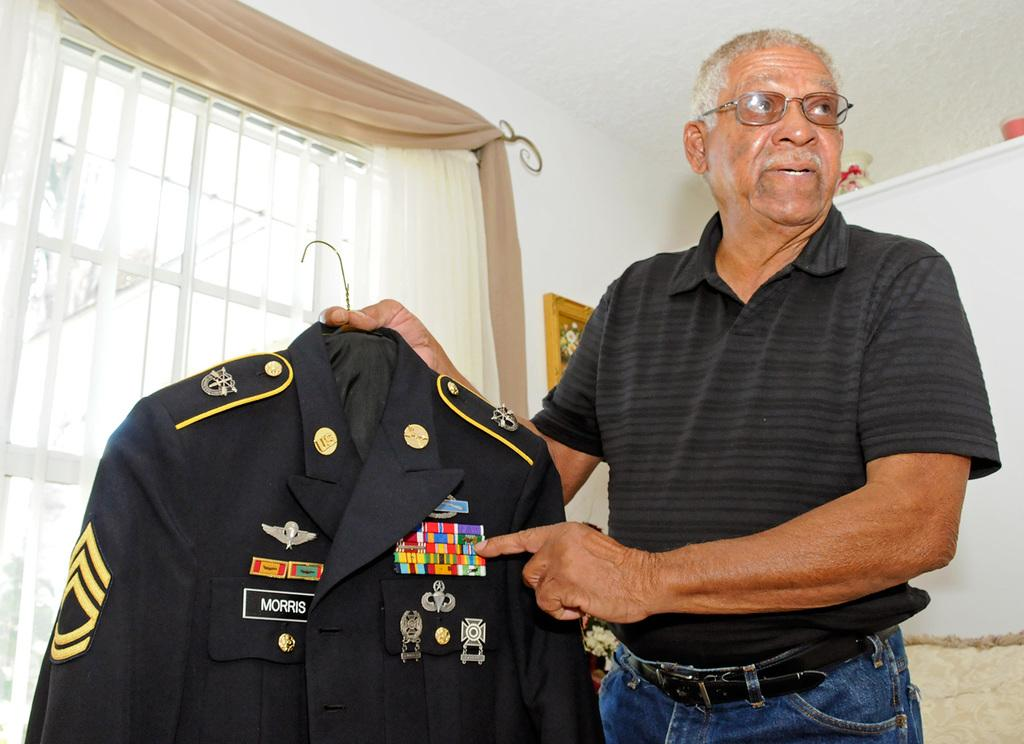What is the man in the image doing? The man is standing in the image. What is the man holding in the image? The man is holding a uniform in the image. Can you describe the uniform? The uniform has some batches. What can be seen in the background of the image? There is a window with a curtain and a wall visible in the image. What type of dress is the man wearing in the image? The man is not wearing a dress in the image; he is holding a uniform. Can you tell me what the man is writing in his notebook in the image? There is no notebook present in the image. 